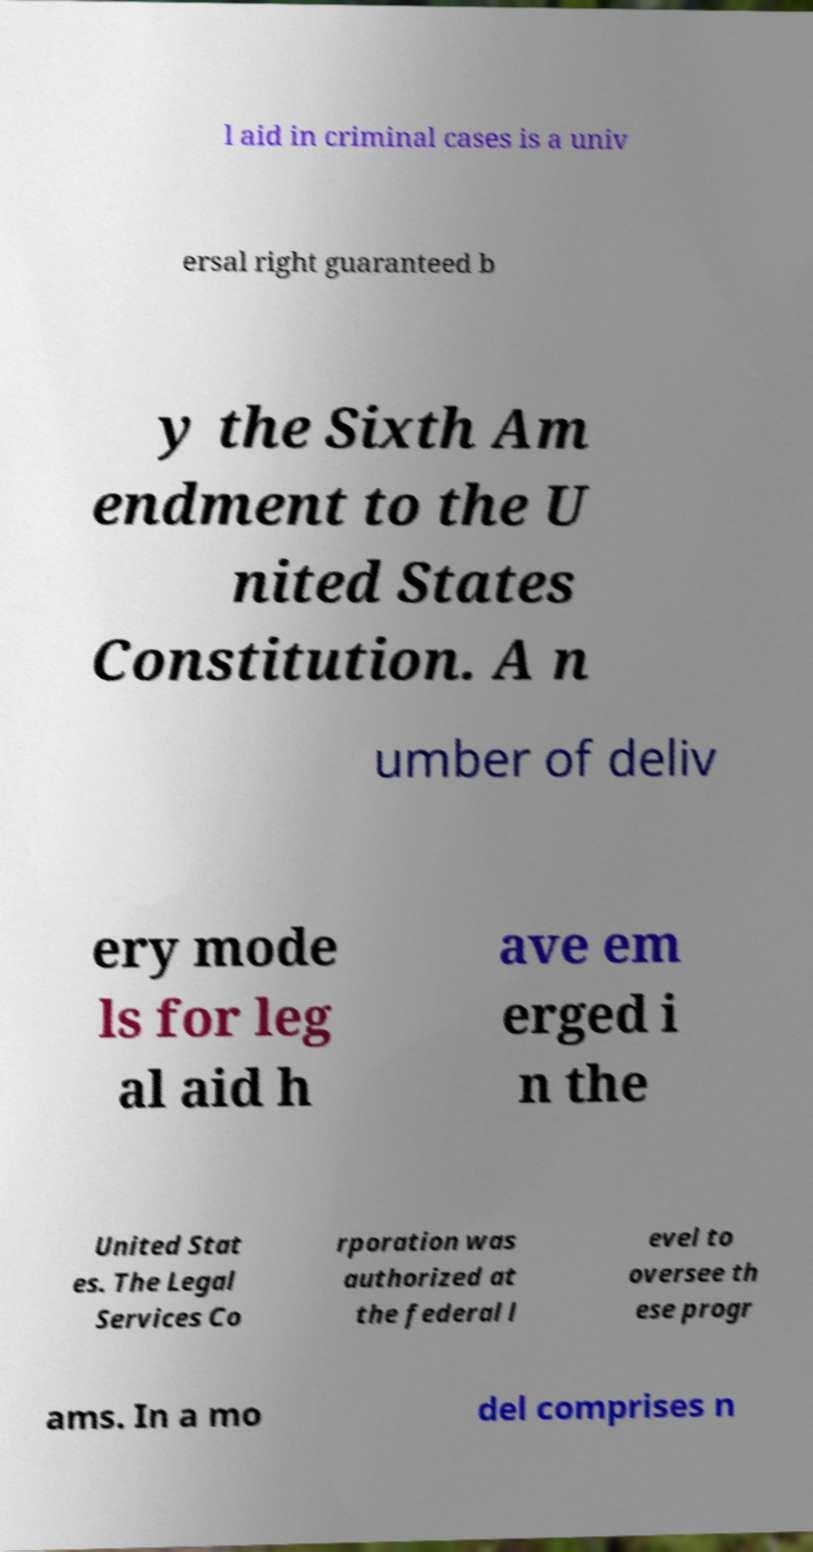Please read and relay the text visible in this image. What does it say? l aid in criminal cases is a univ ersal right guaranteed b y the Sixth Am endment to the U nited States Constitution. A n umber of deliv ery mode ls for leg al aid h ave em erged i n the United Stat es. The Legal Services Co rporation was authorized at the federal l evel to oversee th ese progr ams. In a mo del comprises n 